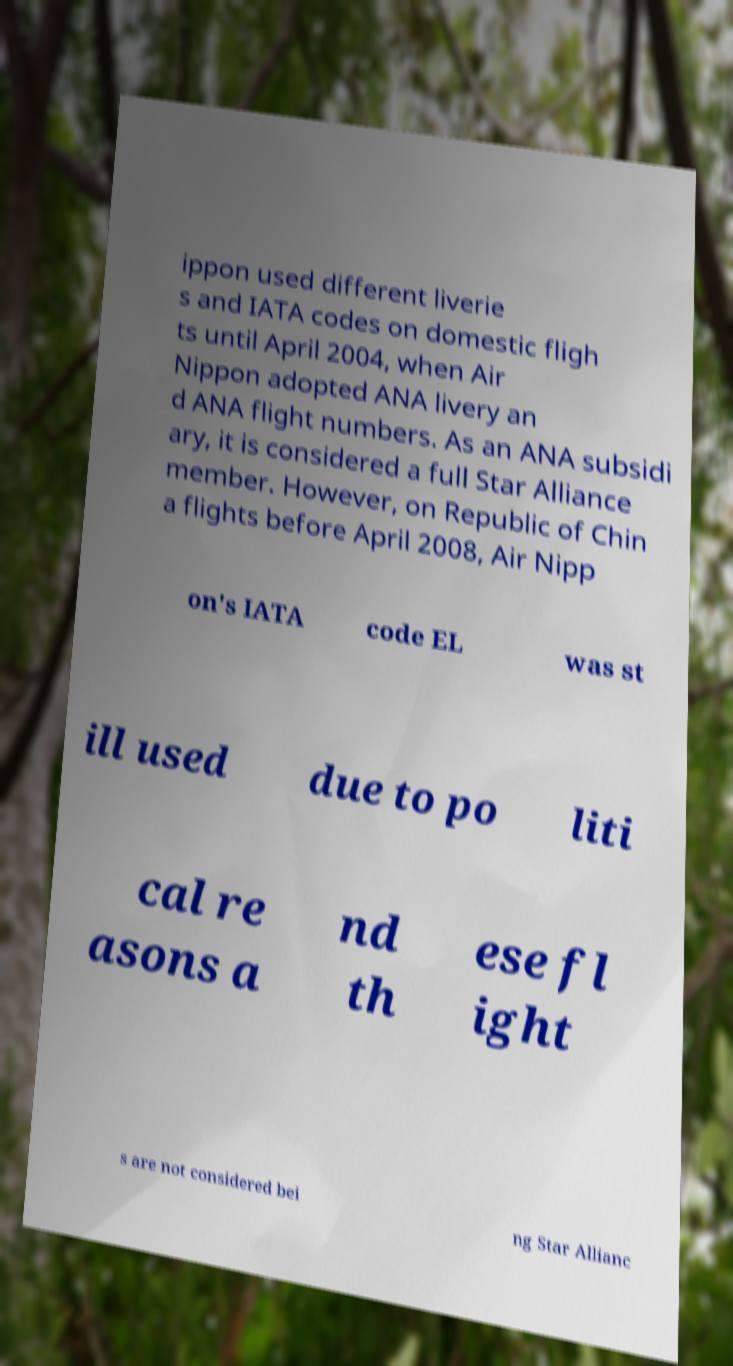There's text embedded in this image that I need extracted. Can you transcribe it verbatim? ippon used different liverie s and IATA codes on domestic fligh ts until April 2004, when Air Nippon adopted ANA livery an d ANA flight numbers. As an ANA subsidi ary, it is considered a full Star Alliance member. However, on Republic of Chin a flights before April 2008, Air Nipp on's IATA code EL was st ill used due to po liti cal re asons a nd th ese fl ight s are not considered bei ng Star Allianc 